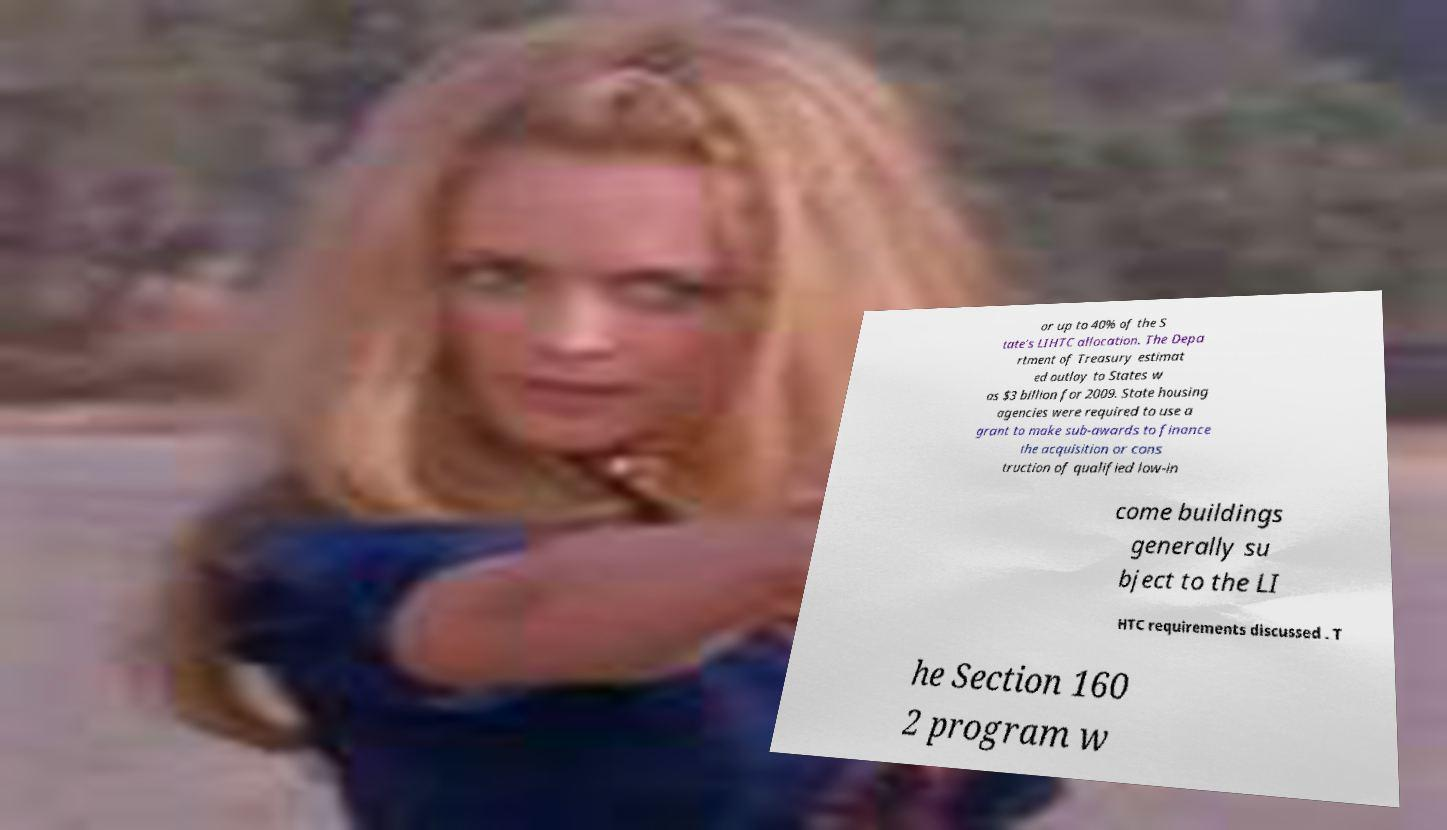Could you extract and type out the text from this image? or up to 40% of the S tate’s LIHTC allocation. The Depa rtment of Treasury estimat ed outlay to States w as $3 billion for 2009. State housing agencies were required to use a grant to make sub-awards to finance the acquisition or cons truction of qualified low-in come buildings generally su bject to the LI HTC requirements discussed . T he Section 160 2 program w 